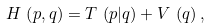<formula> <loc_0><loc_0><loc_500><loc_500>H \, \left ( p , q \right ) = T \, \left ( p | q \right ) + V \, \left ( q \right ) ,</formula> 